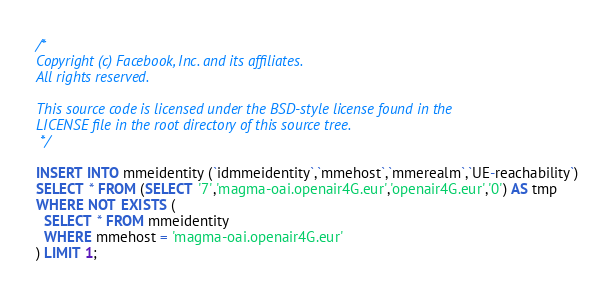Convert code to text. <code><loc_0><loc_0><loc_500><loc_500><_SQL_>/*
Copyright (c) Facebook, Inc. and its affiliates.
All rights reserved.

This source code is licensed under the BSD-style license found in the
LICENSE file in the root directory of this source tree.
 */

INSERT INTO mmeidentity (`idmmeidentity`,`mmehost`,`mmerealm`,`UE-reachability`)
SELECT * FROM (SELECT '7','magma-oai.openair4G.eur','openair4G.eur','0') AS tmp
WHERE NOT EXISTS (
  SELECT * FROM mmeidentity
  WHERE mmehost = 'magma-oai.openair4G.eur'
) LIMIT 1;
</code> 